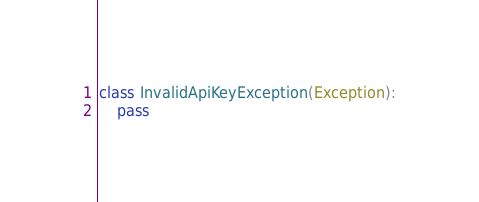<code> <loc_0><loc_0><loc_500><loc_500><_Python_>
class InvalidApiKeyException(Exception):
    pass
</code> 